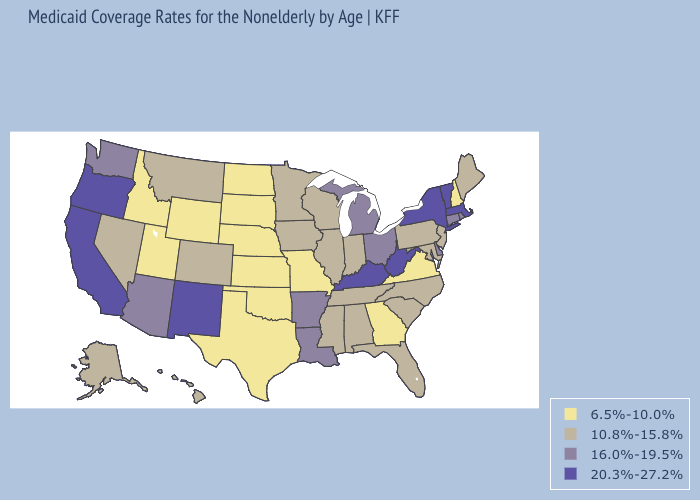What is the value of Missouri?
Keep it brief. 6.5%-10.0%. Does New Jersey have a higher value than Florida?
Keep it brief. No. What is the highest value in states that border Texas?
Answer briefly. 20.3%-27.2%. Which states have the lowest value in the USA?
Answer briefly. Georgia, Idaho, Kansas, Missouri, Nebraska, New Hampshire, North Dakota, Oklahoma, South Dakota, Texas, Utah, Virginia, Wyoming. Does Florida have a lower value than Oklahoma?
Write a very short answer. No. Among the states that border Florida , which have the lowest value?
Be succinct. Georgia. Does Kansas have the highest value in the USA?
Write a very short answer. No. Does New Hampshire have the lowest value in the USA?
Quick response, please. Yes. What is the lowest value in the USA?
Concise answer only. 6.5%-10.0%. What is the value of New Jersey?
Quick response, please. 10.8%-15.8%. Name the states that have a value in the range 10.8%-15.8%?
Keep it brief. Alabama, Alaska, Colorado, Florida, Hawaii, Illinois, Indiana, Iowa, Maine, Maryland, Minnesota, Mississippi, Montana, Nevada, New Jersey, North Carolina, Pennsylvania, South Carolina, Tennessee, Wisconsin. What is the value of Alaska?
Quick response, please. 10.8%-15.8%. Does West Virginia have the lowest value in the USA?
Quick response, please. No. Name the states that have a value in the range 20.3%-27.2%?
Be succinct. California, Kentucky, Massachusetts, New Mexico, New York, Oregon, Vermont, West Virginia. Name the states that have a value in the range 6.5%-10.0%?
Short answer required. Georgia, Idaho, Kansas, Missouri, Nebraska, New Hampshire, North Dakota, Oklahoma, South Dakota, Texas, Utah, Virginia, Wyoming. 